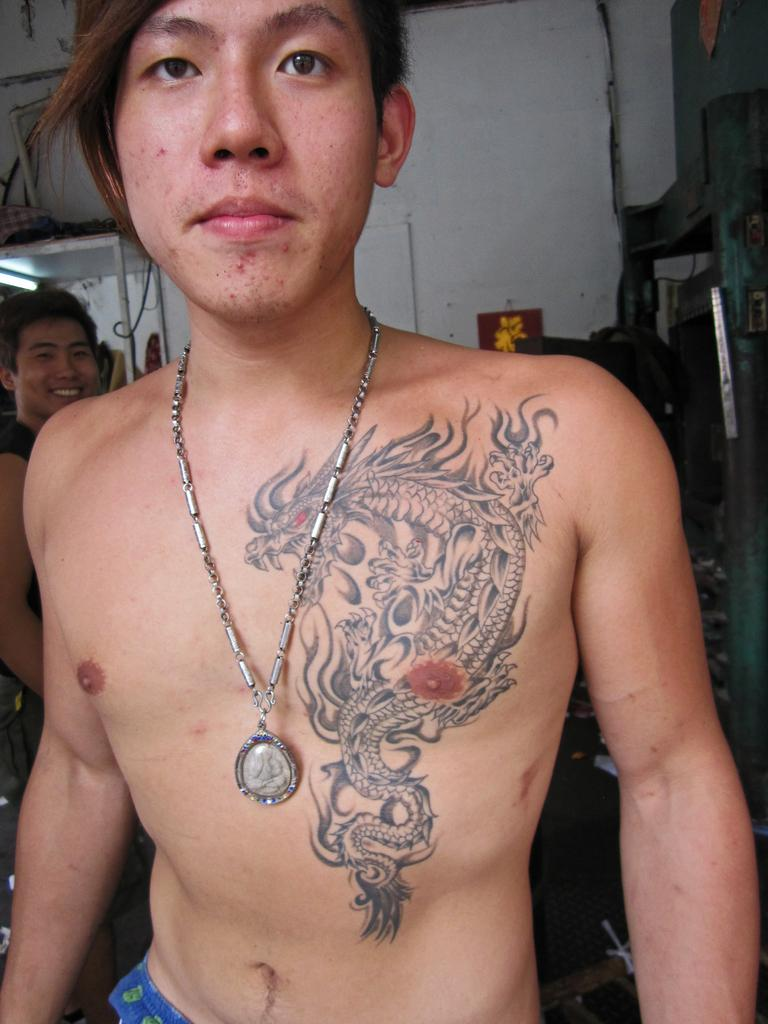What is the main subject of the image? The main subject of the image is a man. Can you describe any distinguishing features of the man? Yes, the man has a tattoo on his body and is wearing a chain. Are there any other people in the image? Yes, there are other people standing behind the man. What is the overall context or setting of the image? The specific nature of the setting is not clearly described, but it may involve other elements or objects. What type of earth can be seen in the bucket held by the man in the image? There is no bucket or earth present in the image; it features a man with a tattoo and a chain, along with other people standing behind him. 